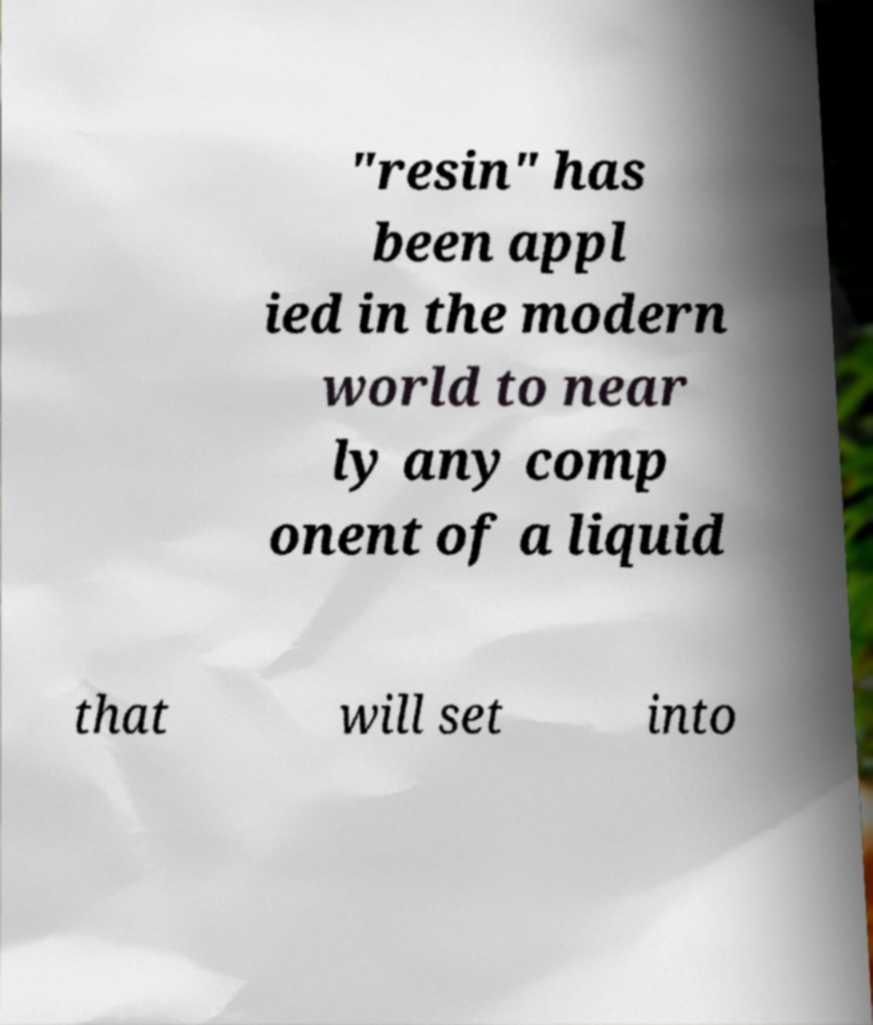Can you read and provide the text displayed in the image?This photo seems to have some interesting text. Can you extract and type it out for me? "resin" has been appl ied in the modern world to near ly any comp onent of a liquid that will set into 